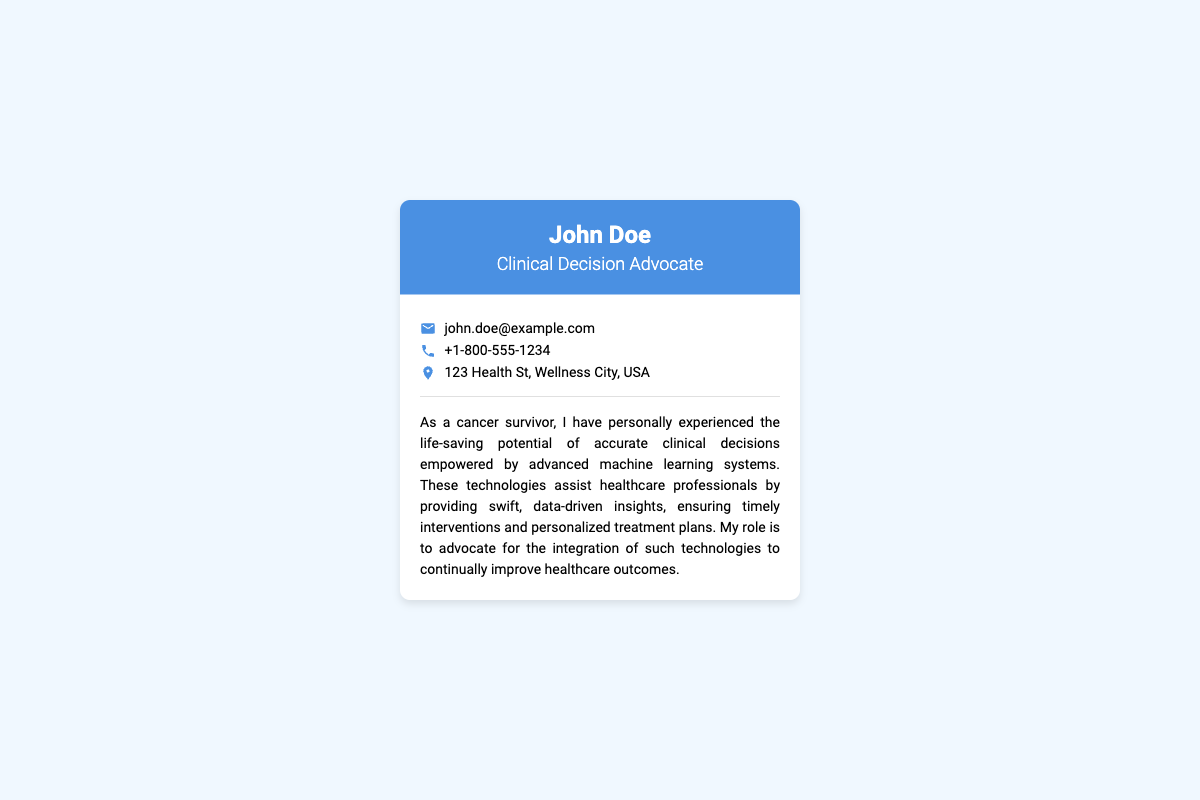What is the name of the Clinical Decision Advocate? The document displays the name at the top of the business card, which is "John Doe."
Answer: John Doe What is the title of the individual on the card? The title is located just below the name, indicating the role in the healthcare context.
Answer: Clinical Decision Advocate What is the email address provided? The email is listed under the contact information section of the document.
Answer: john.doe@example.com What is the phone number listed on the card? The phone number is provided along with the email, to facilitate communication.
Answer: +1-800-555-1234 What is the address on the business card? The address is mentioned in the contact information section.
Answer: 123 Health St, Wellness City, USA Why is John Doe advocating for machine learning in healthcare? The note reveals John Doe's personal experience and the benefits he experienced, indicating his motivation.
Answer: To improve healthcare outcomes What does the business card feature as a background color? The background color is specified in the CSS styling of the document, which sets the visual theme.
Answer: Light blue What type of document is represented? Understanding the formatting and purpose of the document can categorize it accurately.
Answer: Business card How many contact information items are listed on the card? Counting the distinct pieces of contact information can identify the quantity.
Answer: Three 